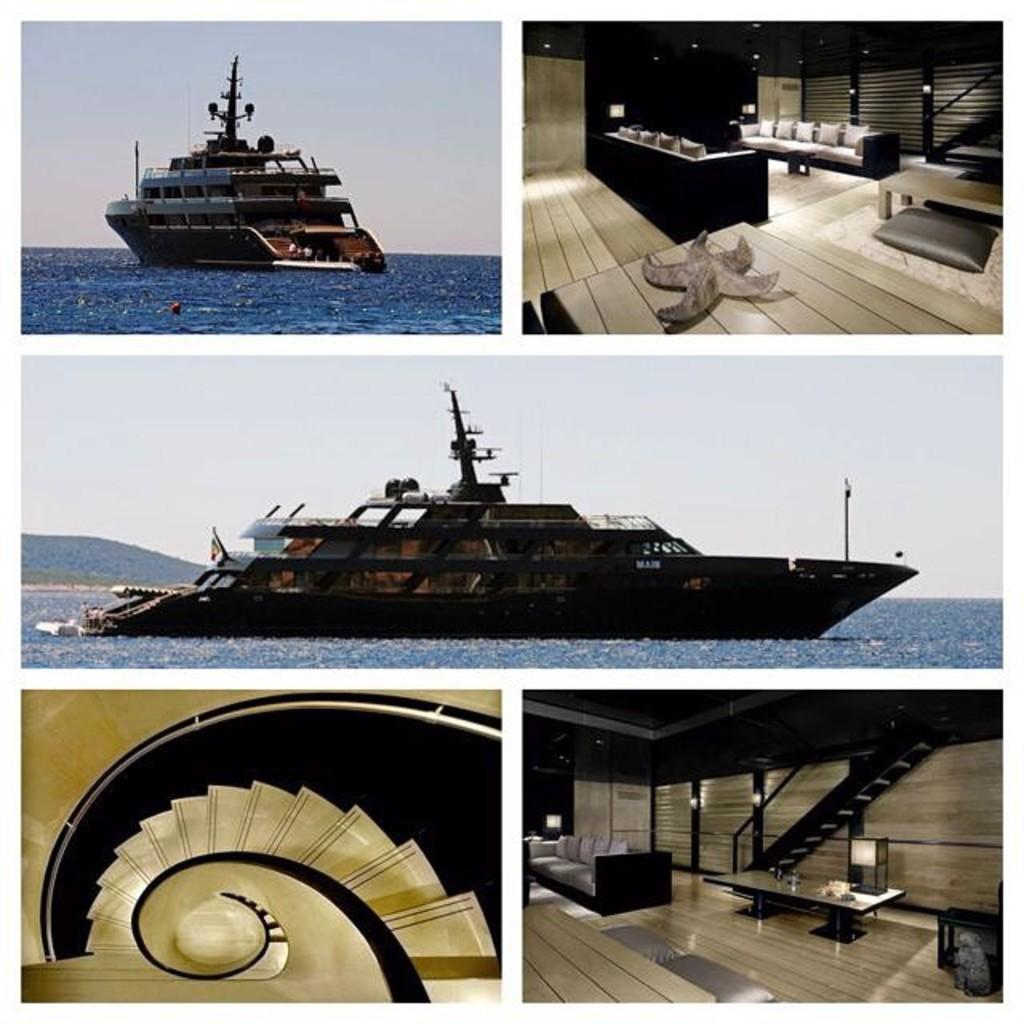What type of artwork is the image? The image is a collage. What is depicted in the water portion of the image? There is a ship on the water in the image. What can be seen in the sky in the image? The sky is visible in the image. What type of surface is present in the image? There is a floor in the image. What type of furniture is in the image? There are pillows on a sofa in the image. What objects are on a table in the image? There are objects on a table in the image. Where is the nest located in the image? There is no nest present in the image. What type of trousers are visible in the image? There are no trousers visible in the image. 